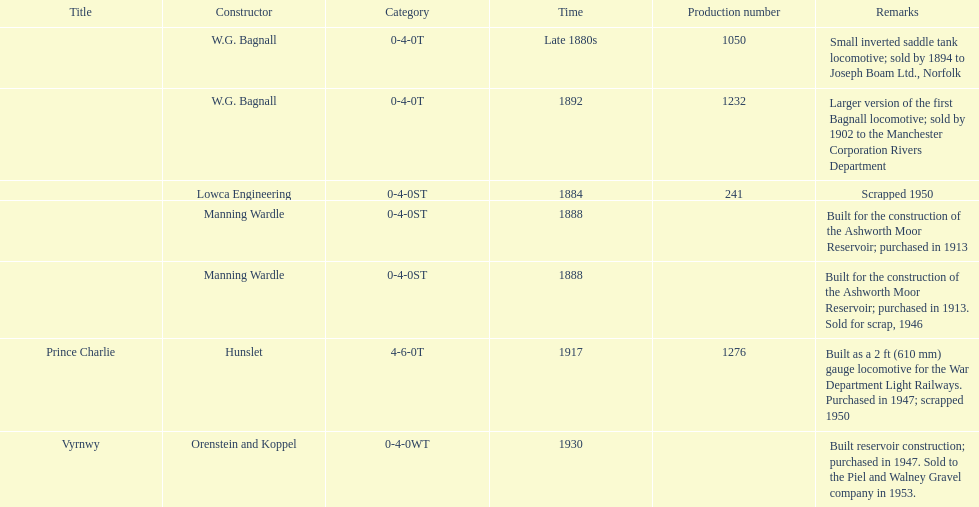Who built the larger version of the first bagnall locomotive? W.G. Bagnall. 